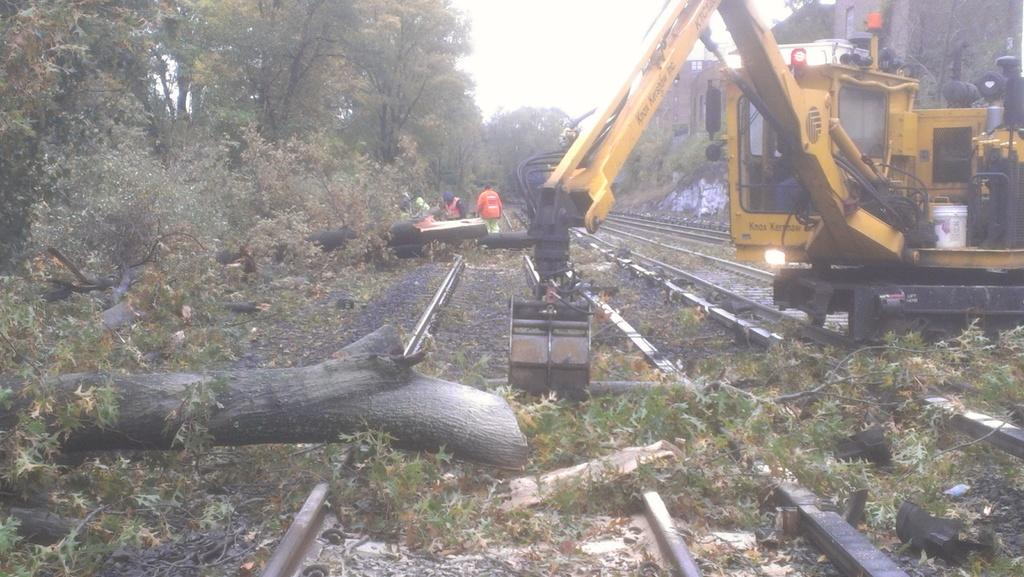What type of vegetation can be seen in the image? There are trees in the image. Who or what is present in the image besides the trees? There are people and a crane in the image. What type of infrastructure is visible in the image? There is a railway track in the image. What is visible at the top of the image? The sky is visible at the top of the image. Can you tell me how many bottles are placed on the railway track in the image? There is no bottle present on the railway track in the image. What type of branch is being used by the people in the image? There is no branch visible in the image; the people are not using any branches. 